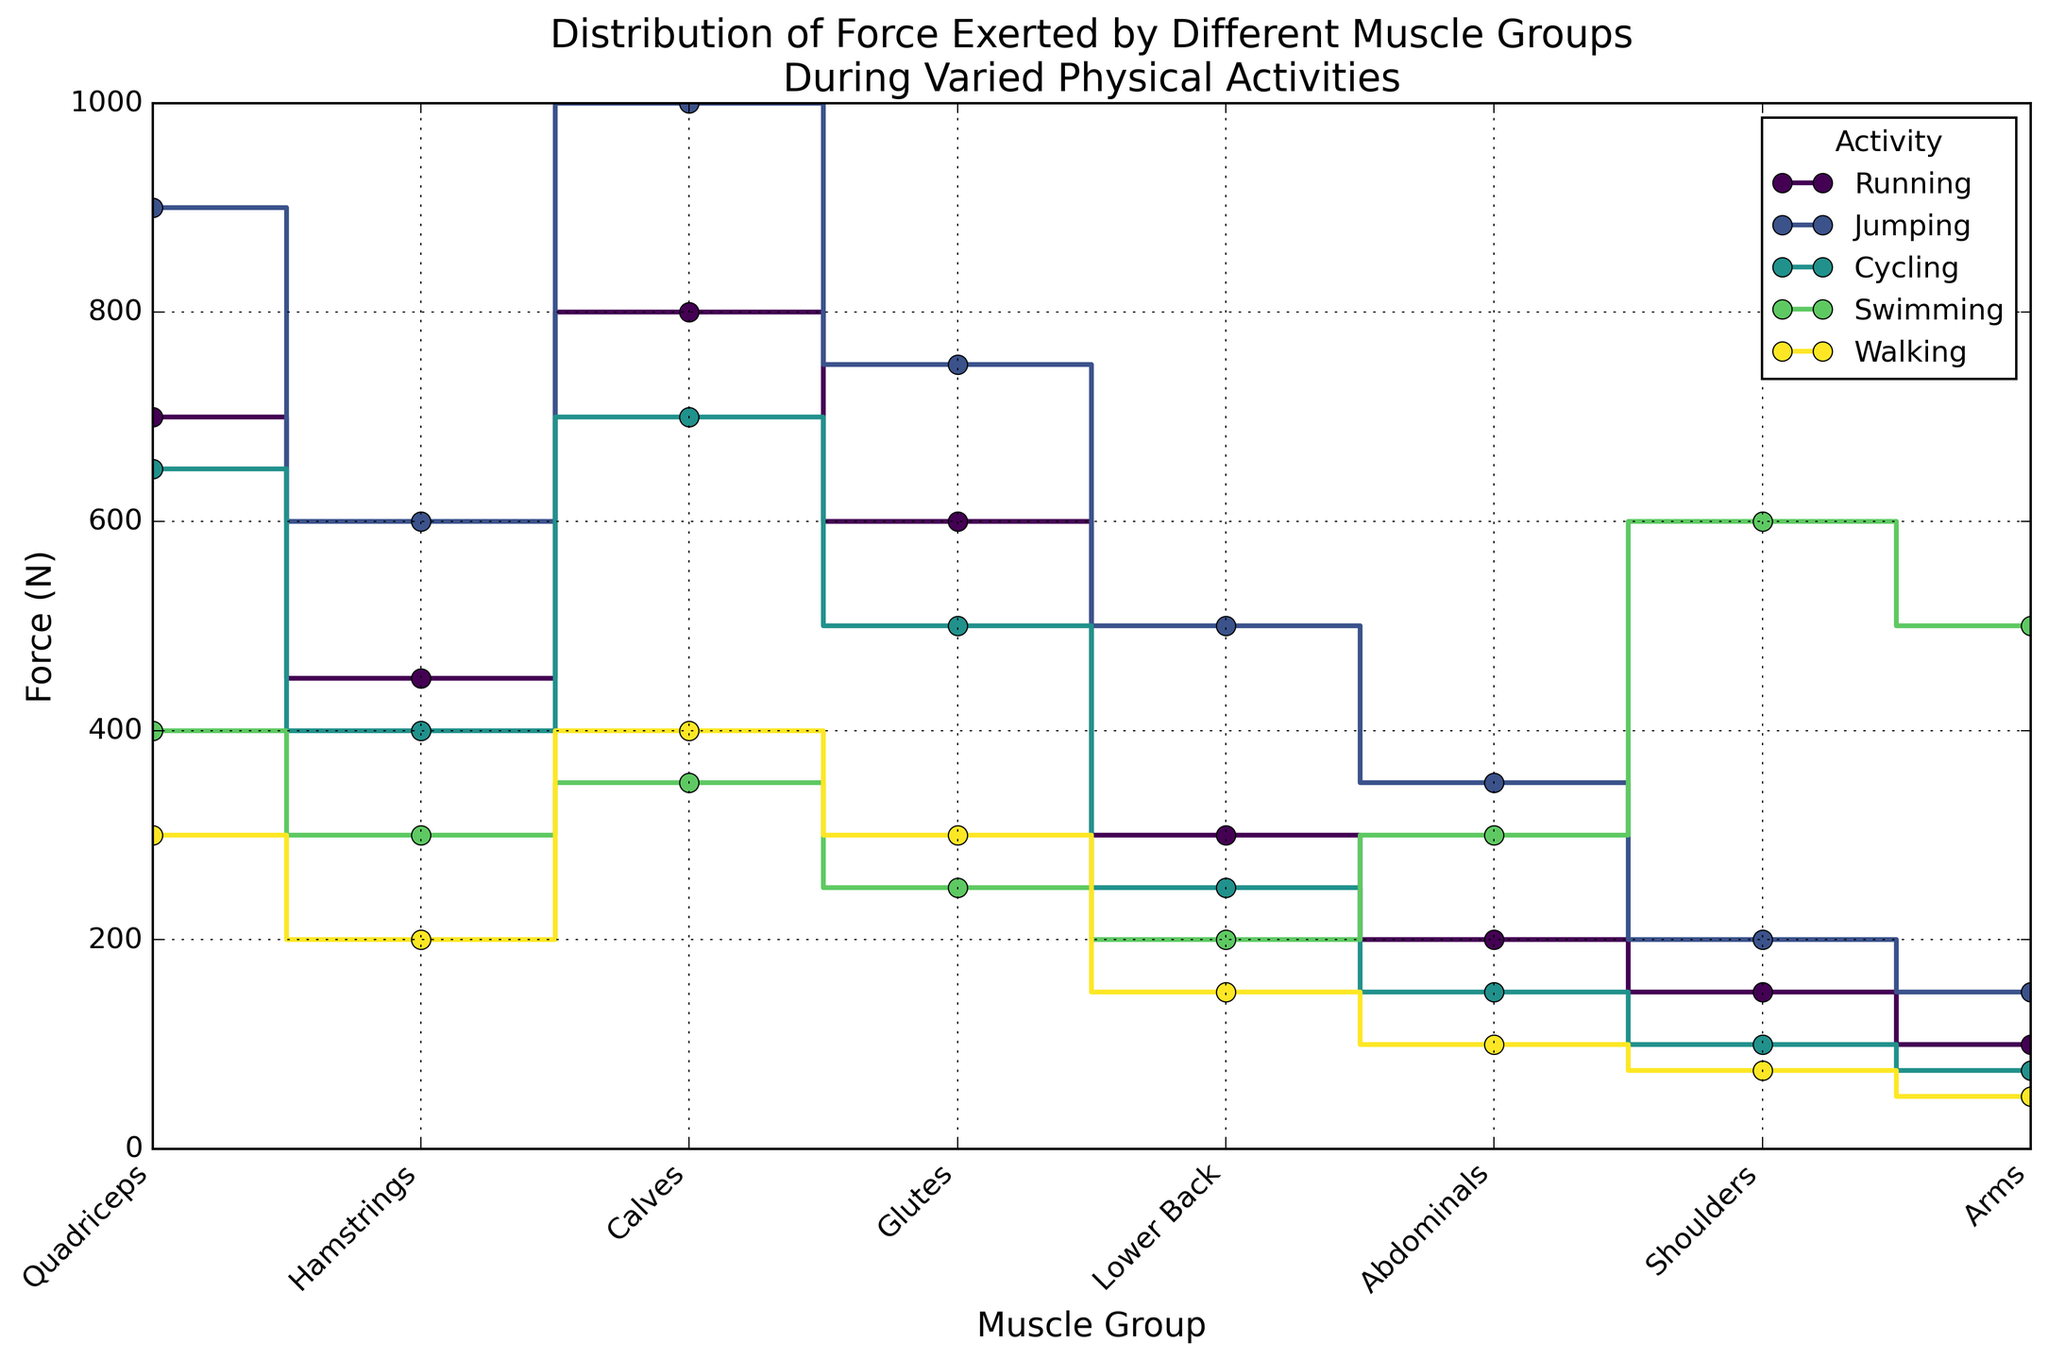What activity shows the highest force exertion in the Quadriceps muscle group? From the plot, the force exertion for different muscle groups is represented for each activity. By observing the 'Quadriceps' specifically, we can see which activity's marker for Quadriceps reaches the highest point. In this case, 'Jumping' shows the highest force exertion.
Answer: Jumping Which muscle group exerts the maximum force during Walking? By checking the heights of the markers for Walking, the 'Calves' have the highest vertical position, indicating it exerts the maximum force.
Answer: Calves What is the total force exerted by the Calves across all activities? Adding the forces exerted by the Calves for each activity: Running (800N) + Jumping (1000N) + Cycling (700N) + Swimming (350N) + Walking (400N) gives us 3250N.
Answer: 3250N Compare the force exerted by the Glutes during Running and Cycling. Which is higher? Looking at the steps corresponding to Glutes for Running and Cycling, we see that the force for Running is 600N, whereas for Cycling it is 500N. Thus, Running shows a higher force exertion.
Answer: Running Which activity shows the least variance in force among all muscle groups? The variance can be visually assessed by the range between the highest and lowest force values for each activity. For Walking, the range appears narrow compared to others, indicating the least variance.
Answer: Walking What is the average force exerted on the Hamstrings during all activities? Adding the forces: Running (450N) + Jumping (600N) + Cycling (400N) + Swimming (300N) + Walking (200N) equals 1950N. Dividing by 5 activities, the average is 1950N/5.
Answer: 390N How does the force exerted by the Shoulders during Swimming compare to that during Running? Observing the markers for Shoulders, Swimming shows a force of 600N compared to 150N during Running. Therefore, the force during Swimming is higher.
Answer: Swimming Which activity has the highest sum of forces across all muscle groups? Summing up forces for each activity: Running (3300N), Jumping (4350N), Cycling (2825N), Swimming (2900N), Walking (1575N). Jumping has the highest sum.
Answer: Jumping What is the difference in force exerted by the Abdominals during Jumping and Walking? For Abdominals, Jumping exerts 350N and Walking exerts 100N. The difference is 350N - 100N.
Answer: 250N Does any muscle group exert the same force across two or more different activities? If so, which ones? Comparing force values for each muscle across activities, the Shoulders show the same force for Running (150N) and Cycling (100N).
Answer: None 